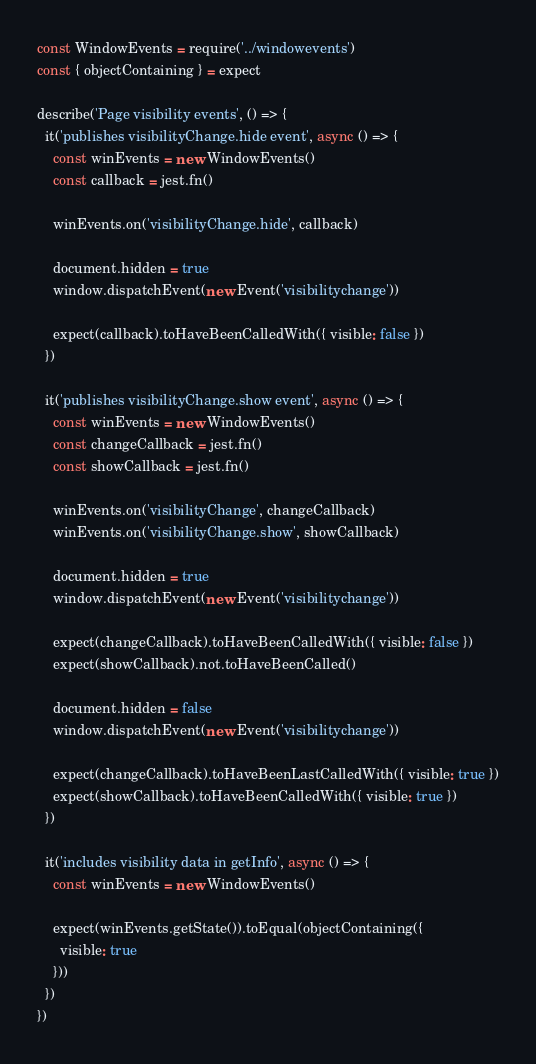Convert code to text. <code><loc_0><loc_0><loc_500><loc_500><_JavaScript_>const WindowEvents = require('../windowevents')
const { objectContaining } = expect

describe('Page visibility events', () => {
  it('publishes visibilityChange.hide event', async () => {
    const winEvents = new WindowEvents()
    const callback = jest.fn()

    winEvents.on('visibilityChange.hide', callback)

    document.hidden = true
    window.dispatchEvent(new Event('visibilitychange'))

    expect(callback).toHaveBeenCalledWith({ visible: false })
  })

  it('publishes visibilityChange.show event', async () => {
    const winEvents = new WindowEvents()
    const changeCallback = jest.fn()
    const showCallback = jest.fn()

    winEvents.on('visibilityChange', changeCallback)
    winEvents.on('visibilityChange.show', showCallback)

    document.hidden = true
    window.dispatchEvent(new Event('visibilitychange'))

    expect(changeCallback).toHaveBeenCalledWith({ visible: false })
    expect(showCallback).not.toHaveBeenCalled()

    document.hidden = false
    window.dispatchEvent(new Event('visibilitychange'))

    expect(changeCallback).toHaveBeenLastCalledWith({ visible: true })
    expect(showCallback).toHaveBeenCalledWith({ visible: true })
  })

  it('includes visibility data in getInfo', async () => {
    const winEvents = new WindowEvents()

    expect(winEvents.getState()).toEqual(objectContaining({
      visible: true
    }))
  })
})
</code> 